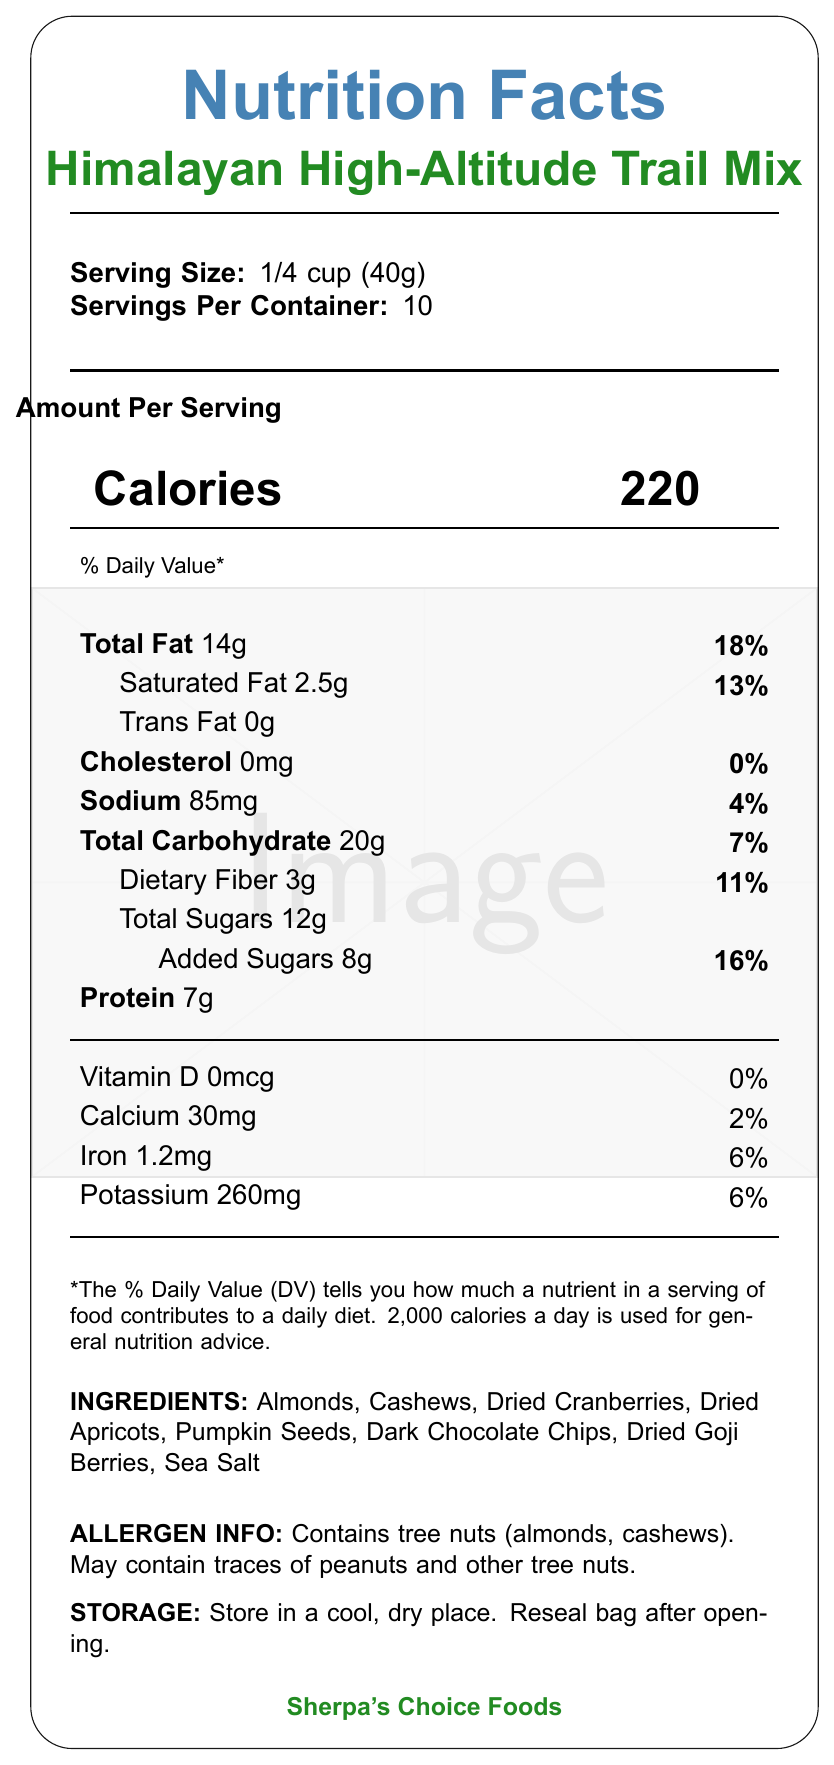what is the serving size? The document explicitly states that the serving size is 1/4 cup (40g).
Answer: 1/4 cup (40g) how many calories are there per serving? The document shows that each serving contains 220 calories.
Answer: 220 what percentage of the daily value is the total fat per serving? The document indicates that the total fat per serving is 14g, which is 18% of the daily value.
Answer: 18% how much protein is there per serving? The document lists the amount of protein per serving as 7g.
Answer: 7g are there any trans fats in the trail mix? The document clearly states that the trans fat amount is 0g.
Answer: No which of the following ingredients is not mentioned in the trail mix? A. Almonds B. Raisins C. Dried Cranberries D. Dark Chocolate Chips Raisins are not listed among the ingredients.
Answer: B what allergens are present in the trail mix? The document specifies that the trail mix contains tree nuts (almonds, cashews) and may contain traces of peanuts and other tree nuts.
Answer: Tree nuts (almonds, cashews) where should the trail mix be stored? The storage instructions in the document indicate it should be stored in a cool, dry place and resealed after opening.
Answer: In a cool, dry place. Reseal bag after opening. can it be determined the company that manufactures the trail mix? The manufacturer is stated as Sherpa's Choice Foods.
Answer: Yes does the trail mix contain any vitamin D? The document shows that the amount of vitamin D in the trail mix is 0mcg, which is 0% of the daily value.
Answer: No what are the recommended altitudes for consuming this trail mix? A. Up to 3,000 meters B. Up to 4,000 meters C. Up to 5,500 meters D. Up to 6,000 meters The document recommends this trail mix for consumption at altitudes up to 5,500 meters (18,000 feet).
Answer: C what is the total carbohydrate amount per serving? The document states that the total carbohydrate amount per serving is 20g.
Answer: 20g what amount of dietary fiber does the trail mix provide per serving? The document indicates that each serving contains 3g of dietary fiber.
Answer: 3g is there any cholesterol in the trail mix? The document specifies that the cholesterol amount is 0mg.
Answer: No what is the main idea of the document? The document is focused on presenting a comprehensive overview of the nutritional content, ingredients, and other essential information about the Himalayan High-Altitude Trail Mix aimed at trekkers.
Answer: The document provides detailed nutrition facts, ingredients list, allergen information, storage instructions, and additional notes for the "Himalayan High-Altitude Trail Mix" manufactured by Sherpa's Choice Foods. The trail mix is designed for high-energy requirements during Himalayan treks and suitable for high-altitude consumption. It emphasizes a mix of nuts, dried fruits, and dark chocolate for balanced nutrition. what is the calorie count of the entire package? The exact calorie count of the entire package cannot be determined explicitly from the document. Only the per-serving calorie count (220 calories) and the number of servings per container (10) are provided.
Answer: Not enough information 